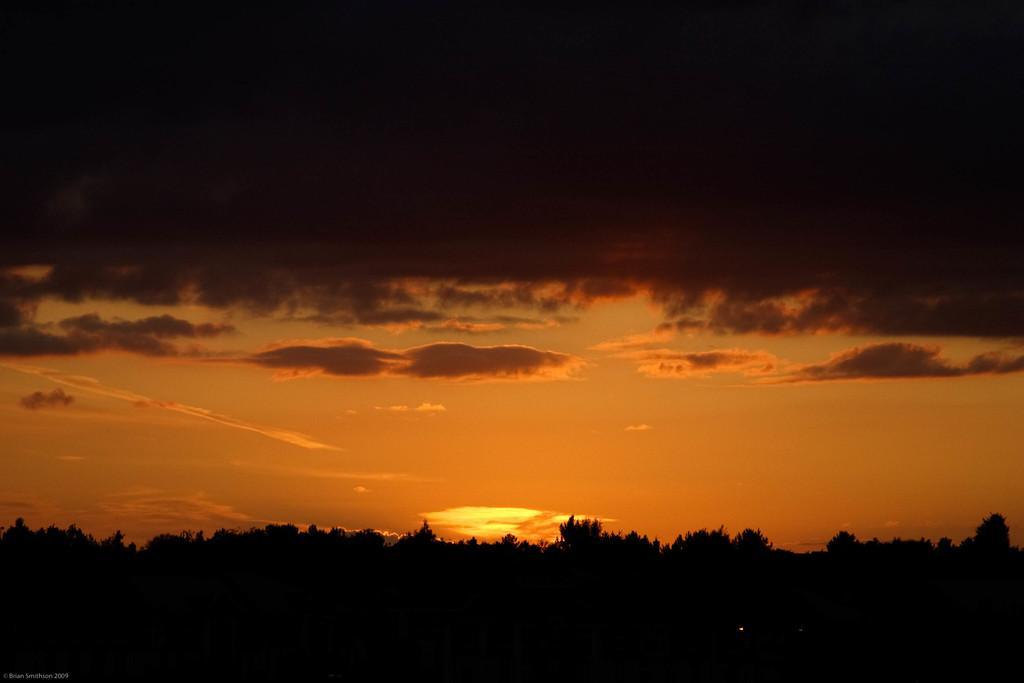Can you describe this image briefly? This image is taken outdoors. At the top of the image there is the sky with clouds and sun. The sky is black and orange in colour. At the bottom of the image there are a few trees and plants on the ground. 